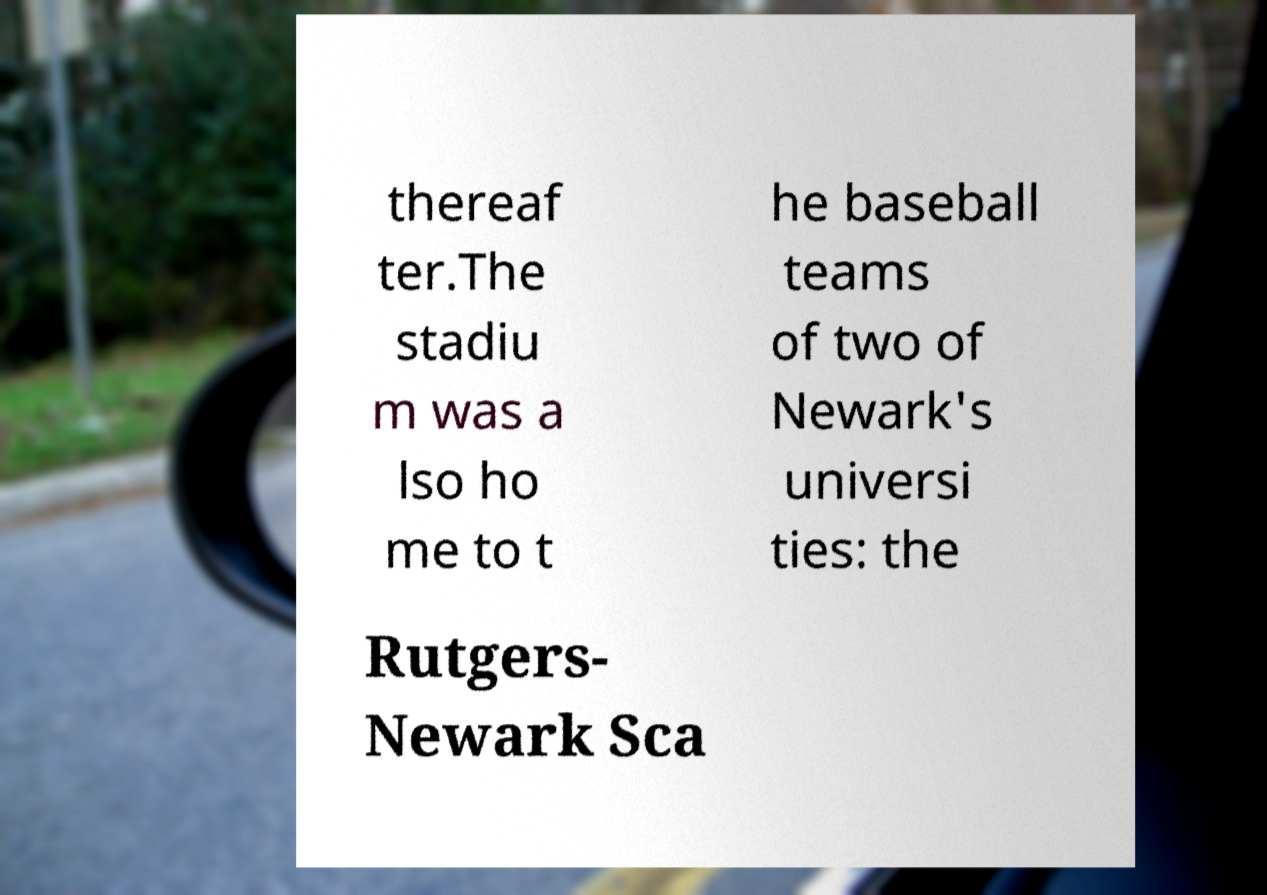Please read and relay the text visible in this image. What does it say? thereaf ter.The stadiu m was a lso ho me to t he baseball teams of two of Newark's universi ties: the Rutgers- Newark Sca 